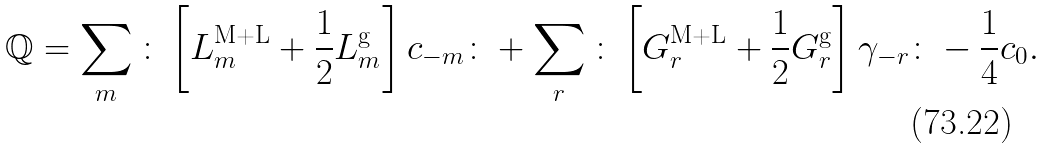<formula> <loc_0><loc_0><loc_500><loc_500>\mathbb { Q } = \sum _ { m } { \colon } \left [ L _ { m } ^ { \text {M+L} } + \frac { 1 } { 2 } L ^ { \text {g} } _ { m } \right ] c _ { - m } { \colon } + \sum _ { r } { \colon } \left [ G _ { r } ^ { \text {M+L} } + \frac { 1 } { 2 } G ^ { \text {g} } _ { r } \right ] \gamma _ { - r } { \colon } - \frac { 1 } { 4 } c _ { 0 } .</formula> 